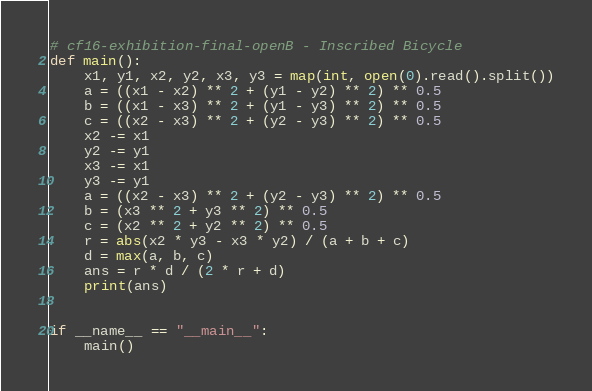Convert code to text. <code><loc_0><loc_0><loc_500><loc_500><_Python_># cf16-exhibition-final-openB - Inscribed Bicycle
def main():
    x1, y1, x2, y2, x3, y3 = map(int, open(0).read().split())
    a = ((x1 - x2) ** 2 + (y1 - y2) ** 2) ** 0.5
    b = ((x1 - x3) ** 2 + (y1 - y3) ** 2) ** 0.5
    c = ((x2 - x3) ** 2 + (y2 - y3) ** 2) ** 0.5
    x2 -= x1
    y2 -= y1
    x3 -= x1
    y3 -= y1
    a = ((x2 - x3) ** 2 + (y2 - y3) ** 2) ** 0.5
    b = (x3 ** 2 + y3 ** 2) ** 0.5
    c = (x2 ** 2 + y2 ** 2) ** 0.5
    r = abs(x2 * y3 - x3 * y2) / (a + b + c)
    d = max(a, b, c)
    ans = r * d / (2 * r + d)
    print(ans)


if __name__ == "__main__":
    main()</code> 